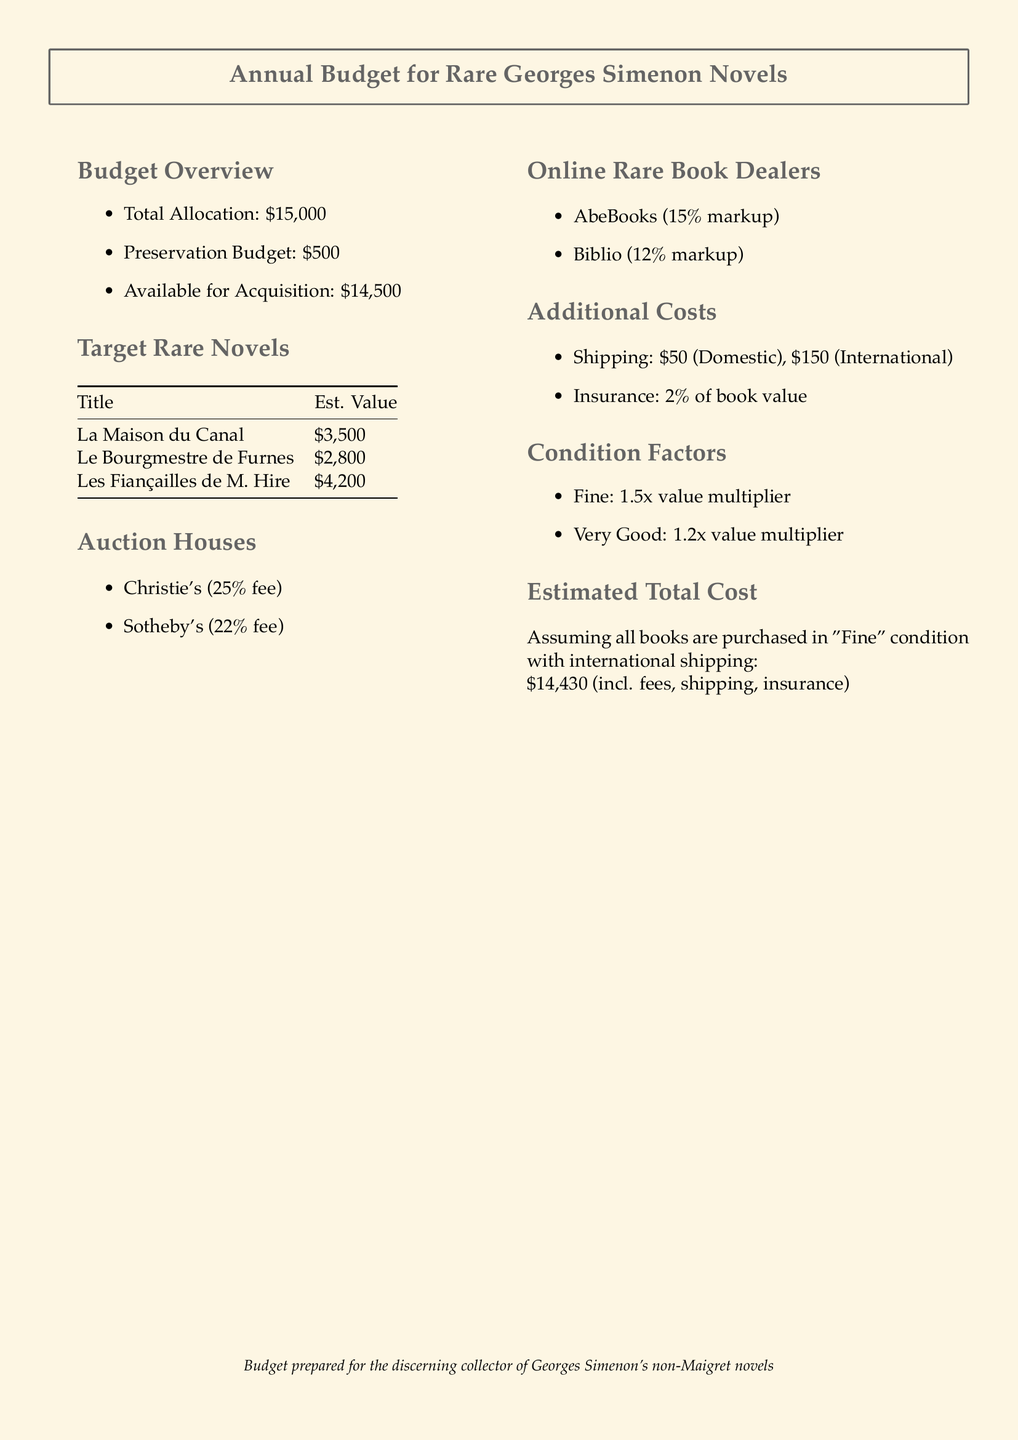what is the total budget allocation? The total budget allocation is clearly stated at the beginning of the budget overview section.
Answer: $15,000 how much is allocated for preservation? The allocated amount for preservation is listed in the budget overview section of the document.
Answer: $500 which auction house has a 25 percent fee? The auction houses are listed in the document, specifying the percentage fees for each.
Answer: Christie's what is the estimated value of "Les Fiançailles de M. Hire"? The estimated value of this novel can be found in the target rare novels table.
Answer: $4,200 what is the shipping cost for international orders? Shipping costs are clearly stated under additional costs in the document.
Answer: $150 what is the insurance rate for a book? The document specifies the insurance rate as a percentage of the book value.
Answer: 2% what is the value multiplier for "Fine" condition? The document lists condition factors with their respective multipliers.
Answer: 1.5x what is the estimated total cost assuming "Fine" condition? The estimated total cost is mentioned towards the end of the document, considering the specified conditions.
Answer: $14,430 what is the markup for AbeBooks? The online rare book dealers and their markups are listed in the document.
Answer: 15% 